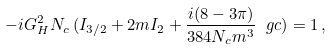<formula> <loc_0><loc_0><loc_500><loc_500>- i G _ { H } ^ { 2 } N _ { c } \, ( I _ { 3 / 2 } + 2 m I _ { 2 } + \frac { i ( 8 - 3 \pi ) } { 3 8 4 N _ { c } m ^ { 3 } } \ g c ) = 1 \, ,</formula> 